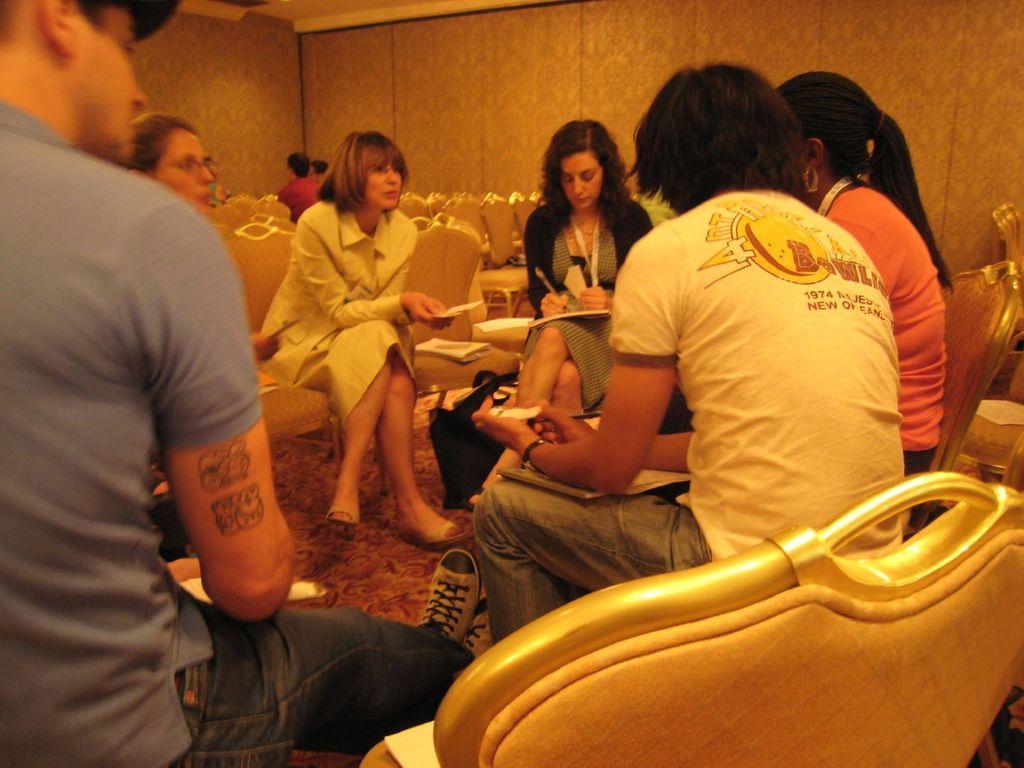Can you describe this image briefly? In the image we can see there are people who are sitting on chair and the woman over here is wearing a id card in her neck and she is holding a pen and there is a paper on her lap and the man over here is having tattoo on his shoulder. 